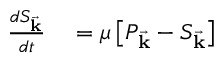<formula> <loc_0><loc_0><loc_500><loc_500>\begin{array} { r l } { \frac { d S _ { \vec { k } } } { d t } } & = \mu \left [ P _ { \vec { k } } - S _ { \vec { k } } \right ] } \end{array}</formula> 